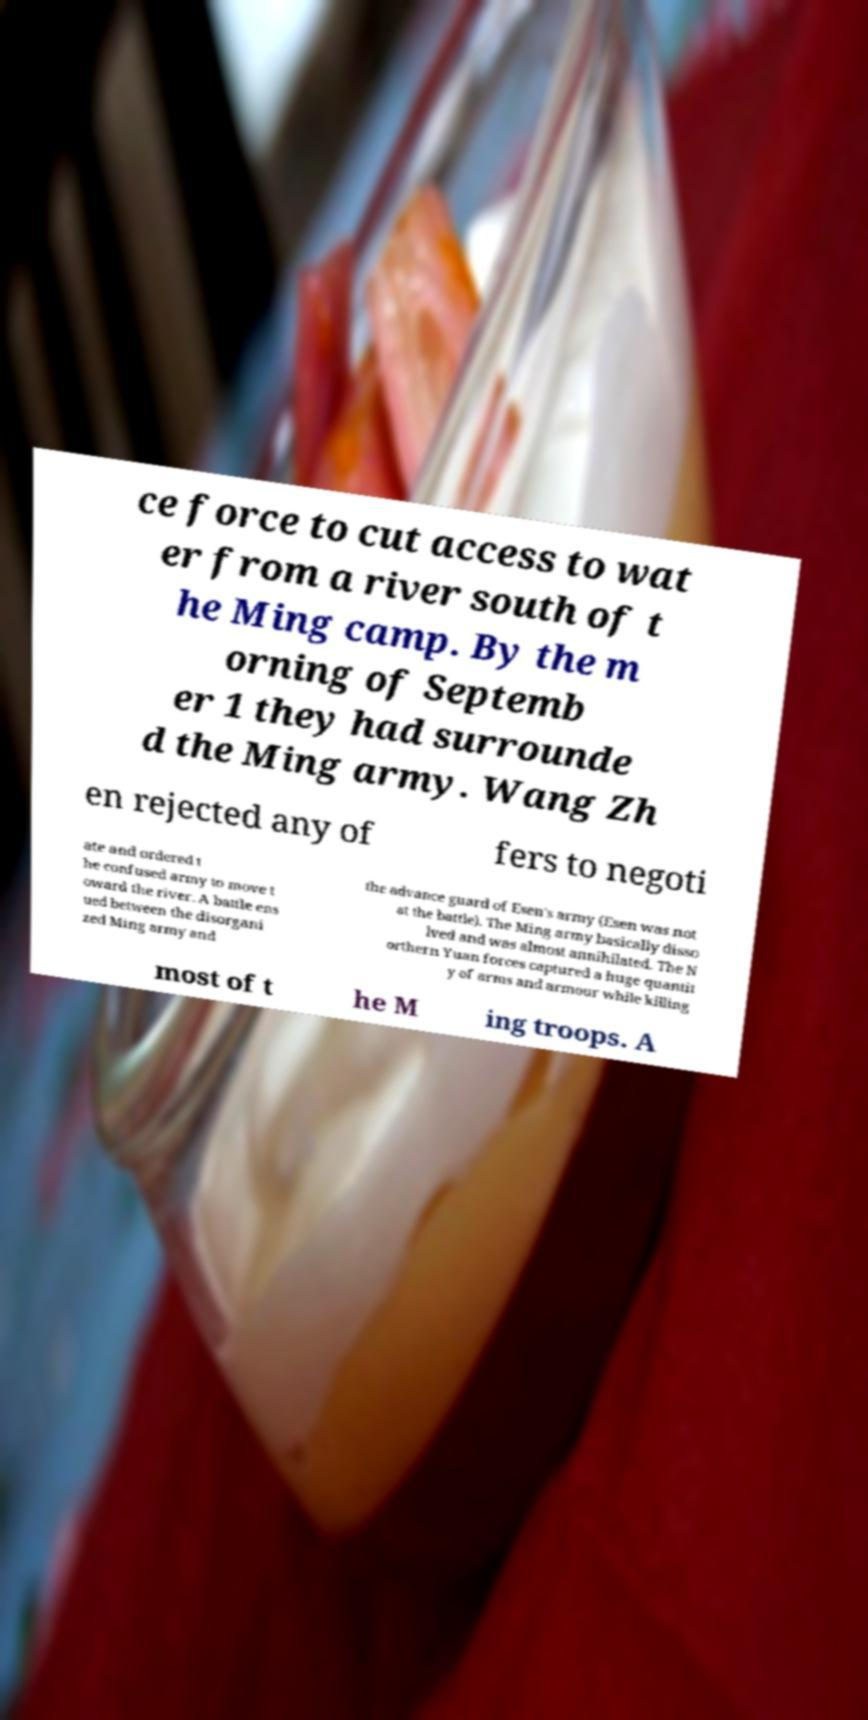There's text embedded in this image that I need extracted. Can you transcribe it verbatim? ce force to cut access to wat er from a river south of t he Ming camp. By the m orning of Septemb er 1 they had surrounde d the Ming army. Wang Zh en rejected any of fers to negoti ate and ordered t he confused army to move t oward the river. A battle ens ued between the disorgani zed Ming army and the advance guard of Esen's army (Esen was not at the battle). The Ming army basically disso lved and was almost annihilated. The N orthern Yuan forces captured a huge quantit y of arms and armour while killing most of t he M ing troops. A 